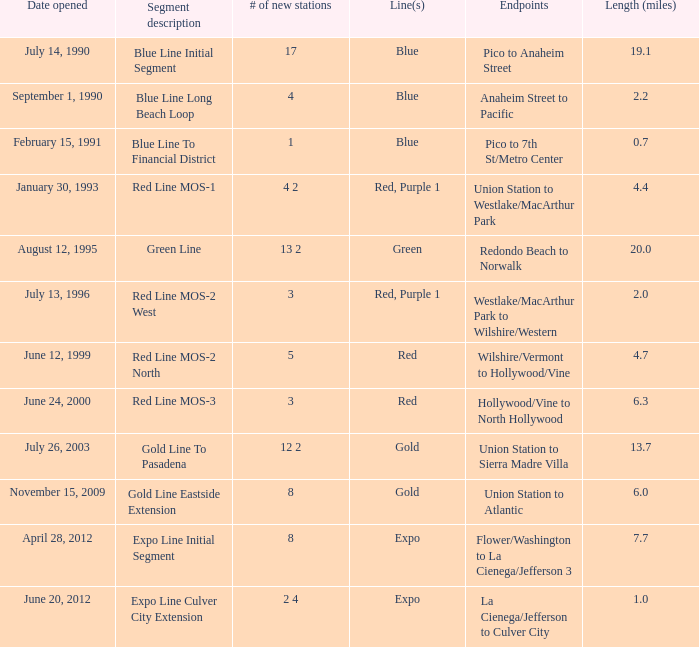What is the length  (miles) when pico to 7th st/metro center are the endpoints? 0.7. 